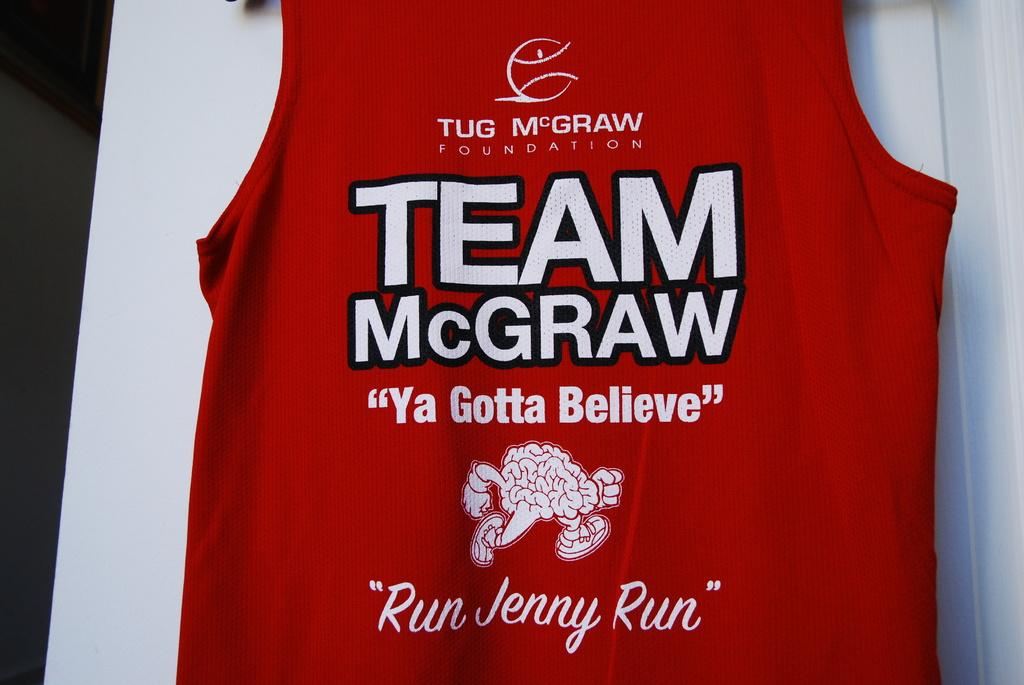Provide a one-sentence caption for the provided image. A red jersey that says Team McGraw on it. 